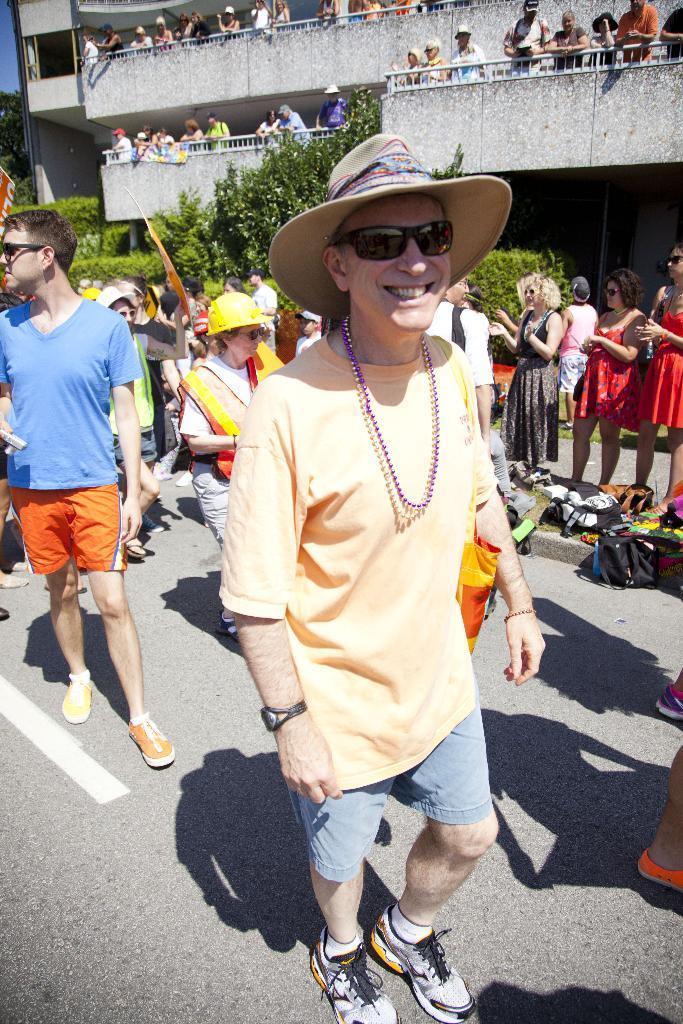Please provide a concise description of this image. In this picture there is a man who is wearing hat, goggle, t-shirt, match, trouser and shoes. In the back I can see many people who are standing on the road. In the background I can see many persons who are standing on the balcony. In the back I can see the building. On the left I can see the trees, plants. On the right I can see some bags and clothes. 